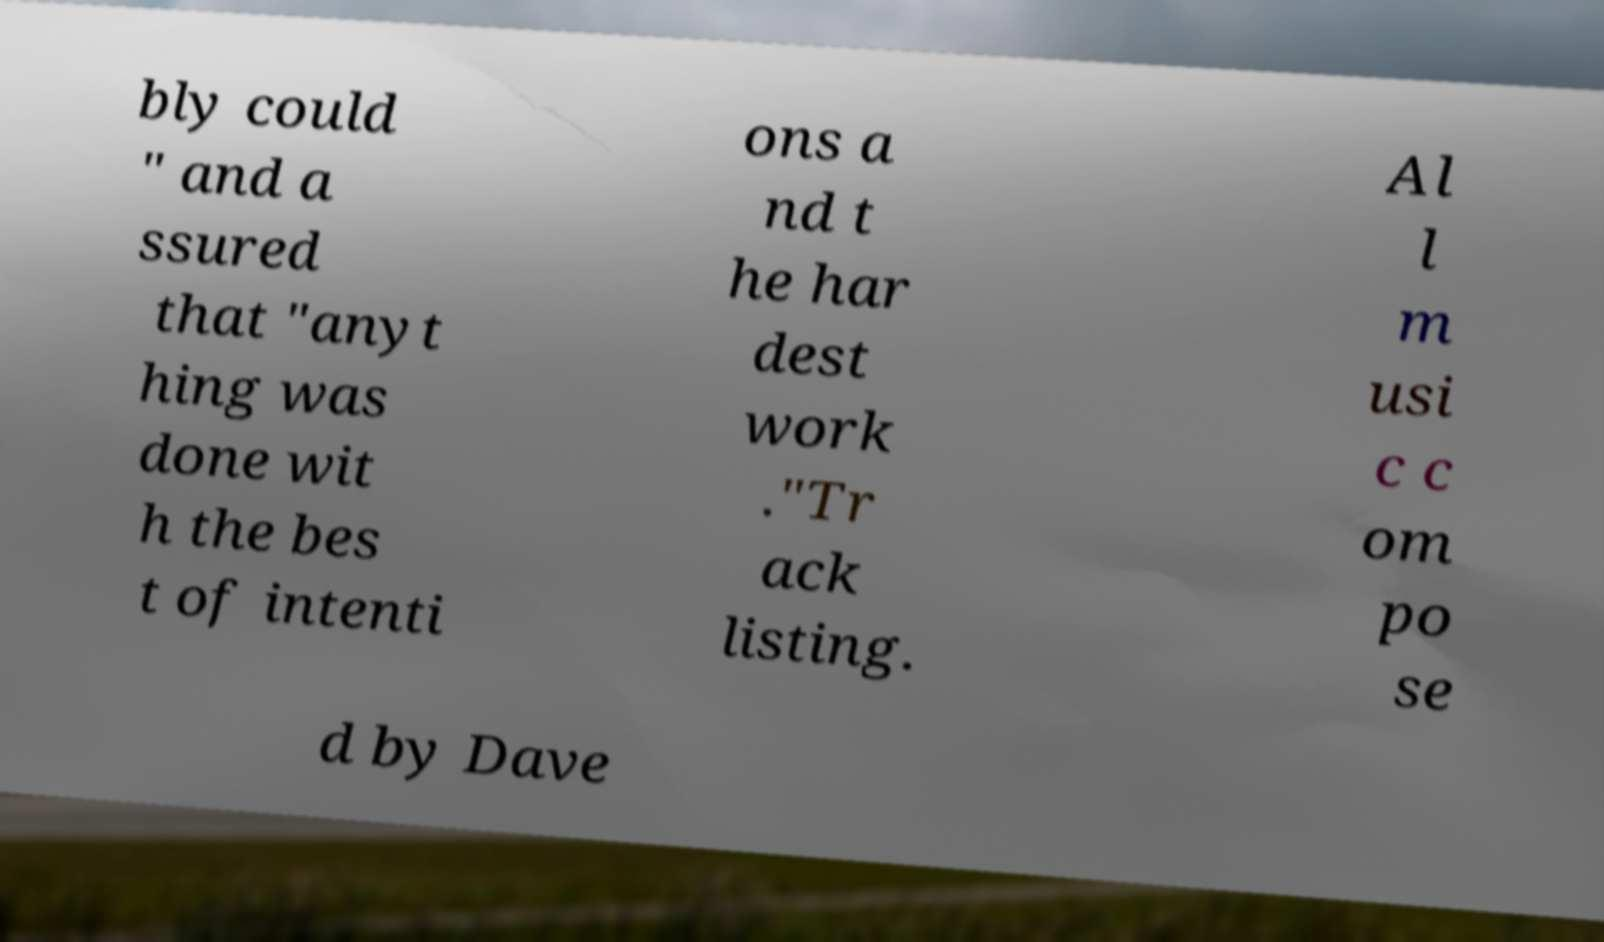There's text embedded in this image that I need extracted. Can you transcribe it verbatim? bly could " and a ssured that "anyt hing was done wit h the bes t of intenti ons a nd t he har dest work ."Tr ack listing. Al l m usi c c om po se d by Dave 